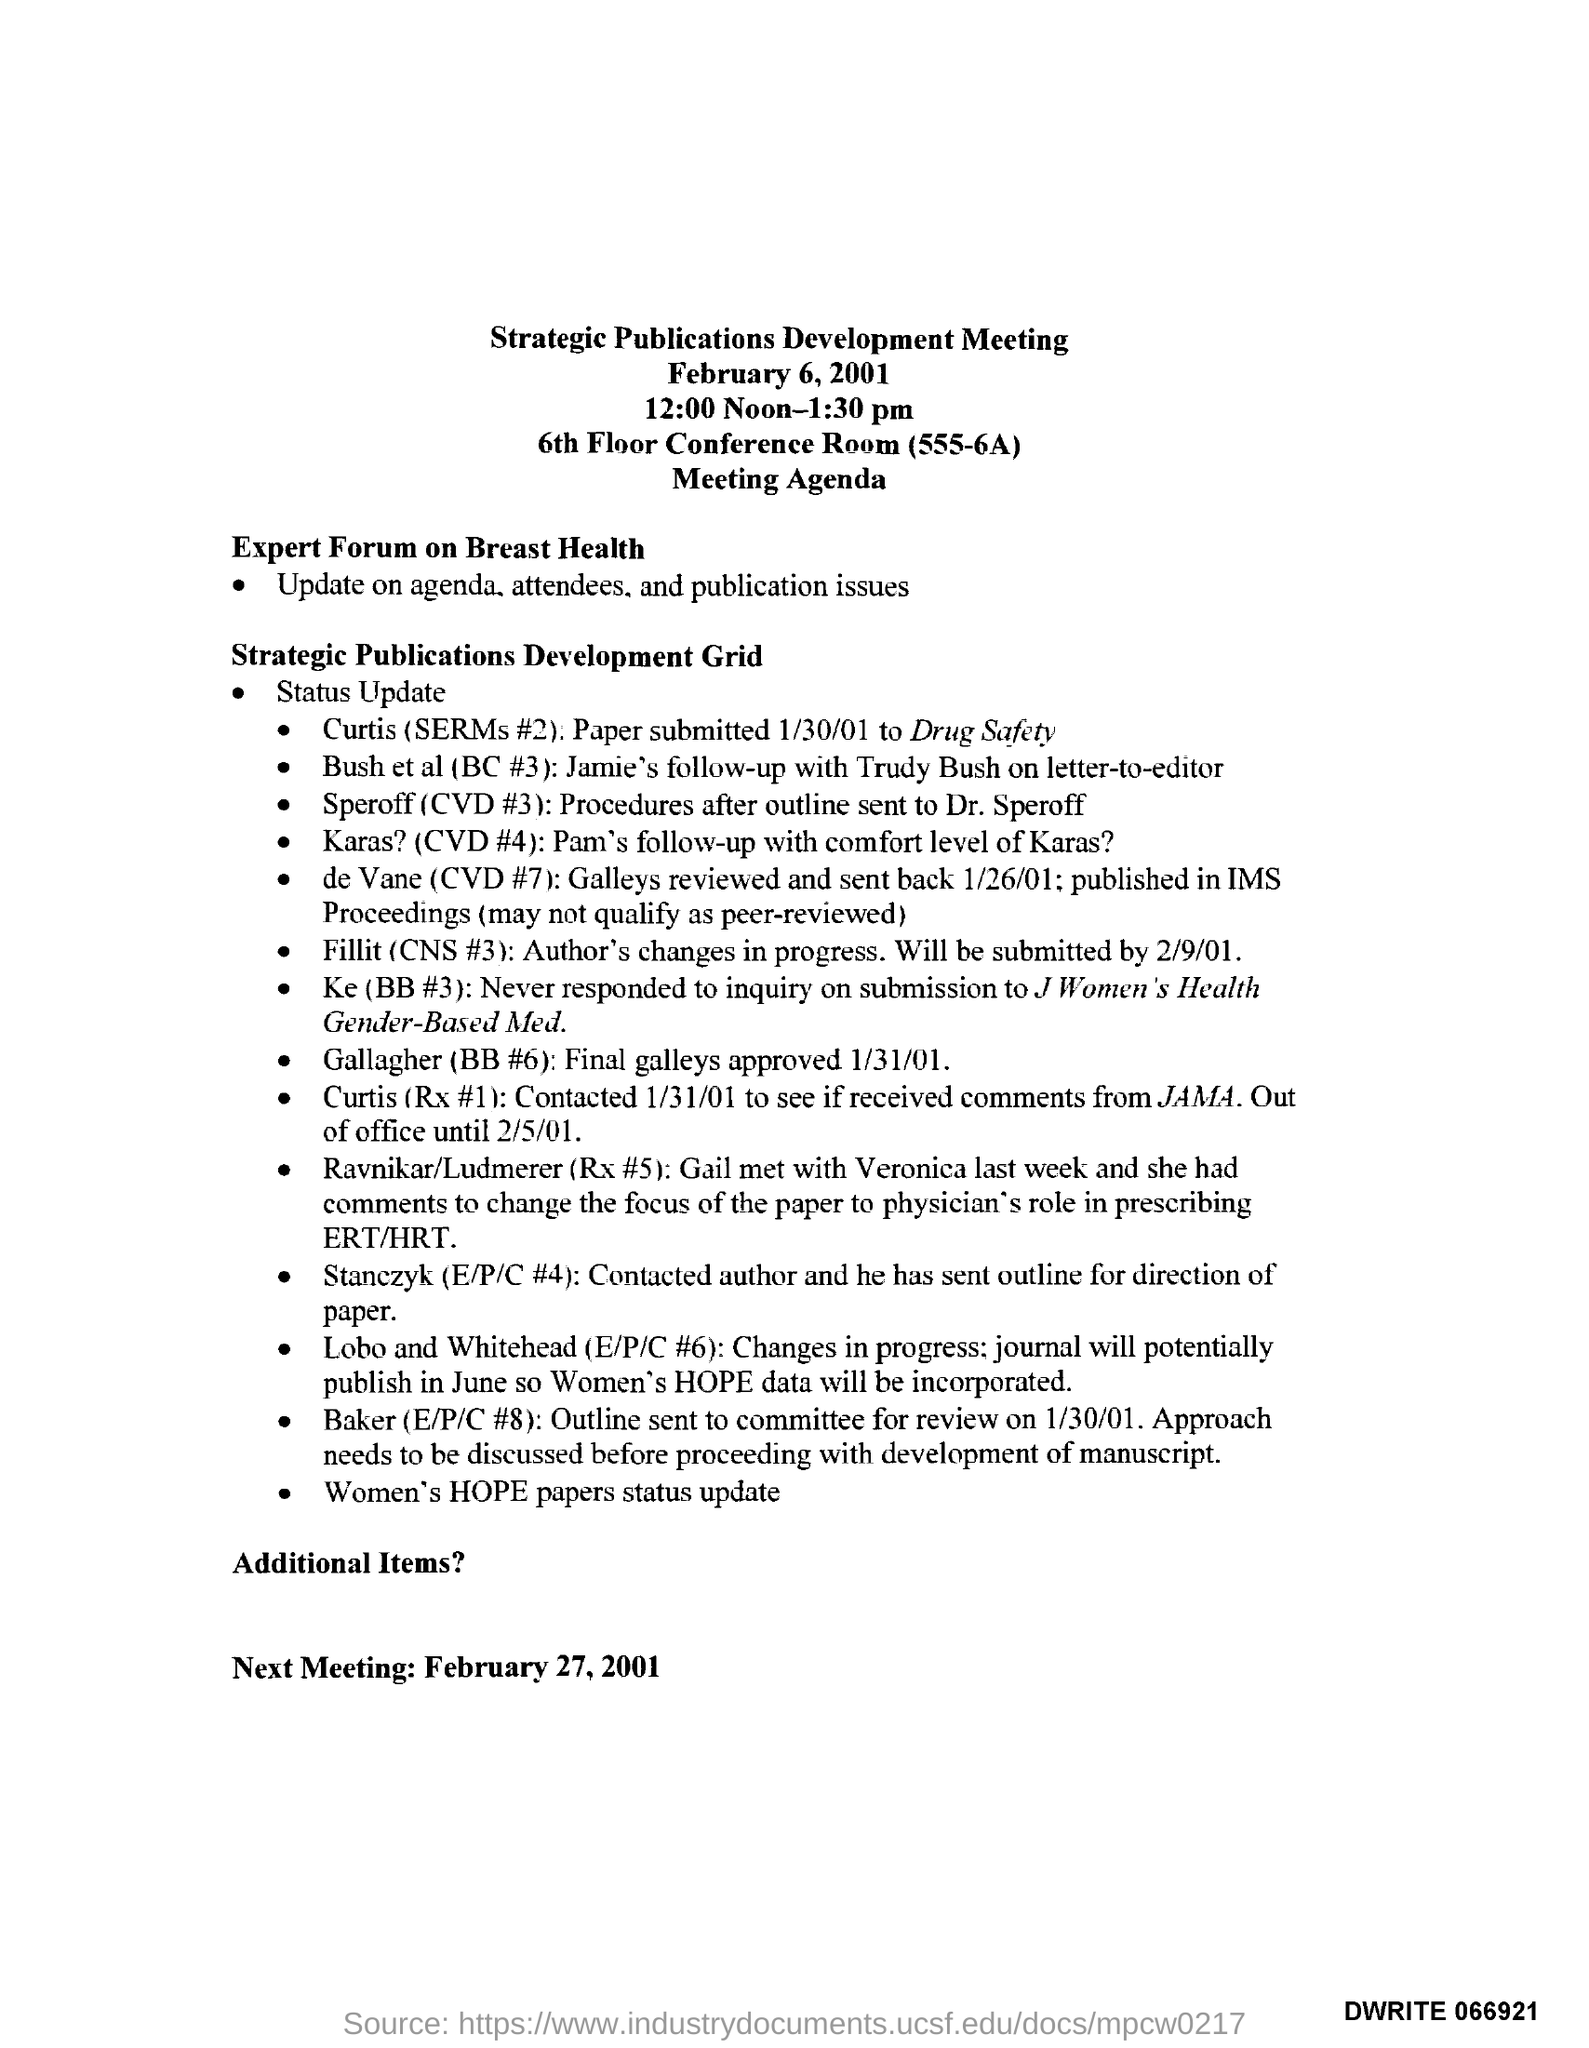Indicate a few pertinent items in this graphic. The Strategic Publications Development Meeting will be held at the 6th Floor Conference Room (555-6A) in a specific location. The Strategic Publications Development Meeting is scheduled for 12:00 Noon-1:30 pm. The Expert forum on Breast Health provides updates on its agenda, attendees, and publication issues. The Strategic Publications Development Meeting was held on February 6, 2001. 